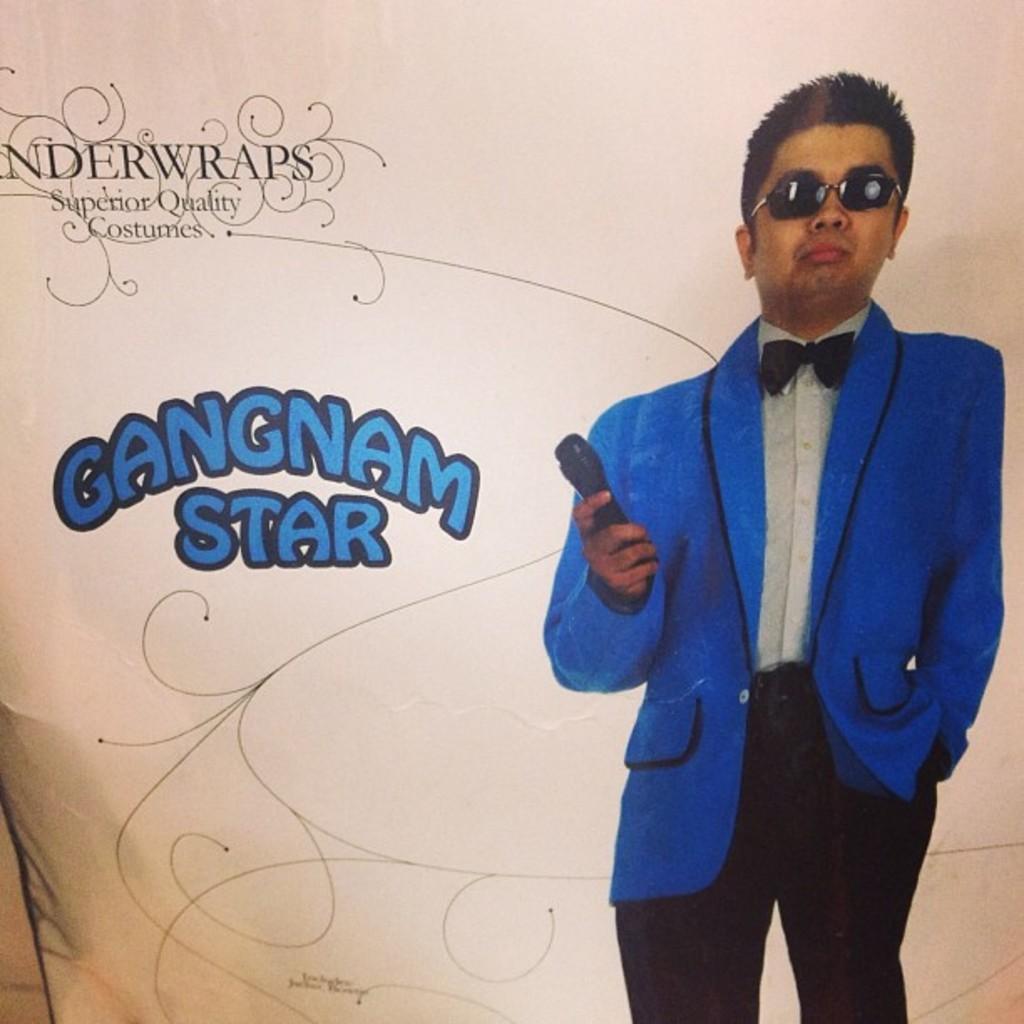In one or two sentences, can you explain what this image depicts? Here in this picture we can see a poster, on which we can see a person in a blue colored blazer standing and he is holding a microphone in his hand and wearing goggles on him and beside him we can see some text present. 